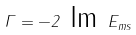<formula> <loc_0><loc_0><loc_500><loc_500>\Gamma = - 2 \text { Im } E _ { m s }</formula> 